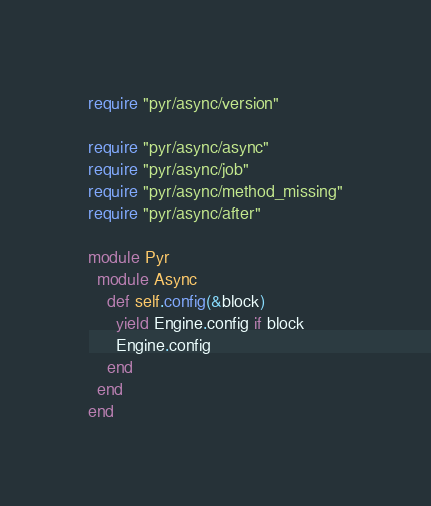<code> <loc_0><loc_0><loc_500><loc_500><_Ruby_>require "pyr/async/version"

require "pyr/async/async"
require "pyr/async/job"
require "pyr/async/method_missing"
require "pyr/async/after"

module Pyr
  module Async
    def self.config(&block)
      yield Engine.config if block
      Engine.config
    end
  end
end

</code> 